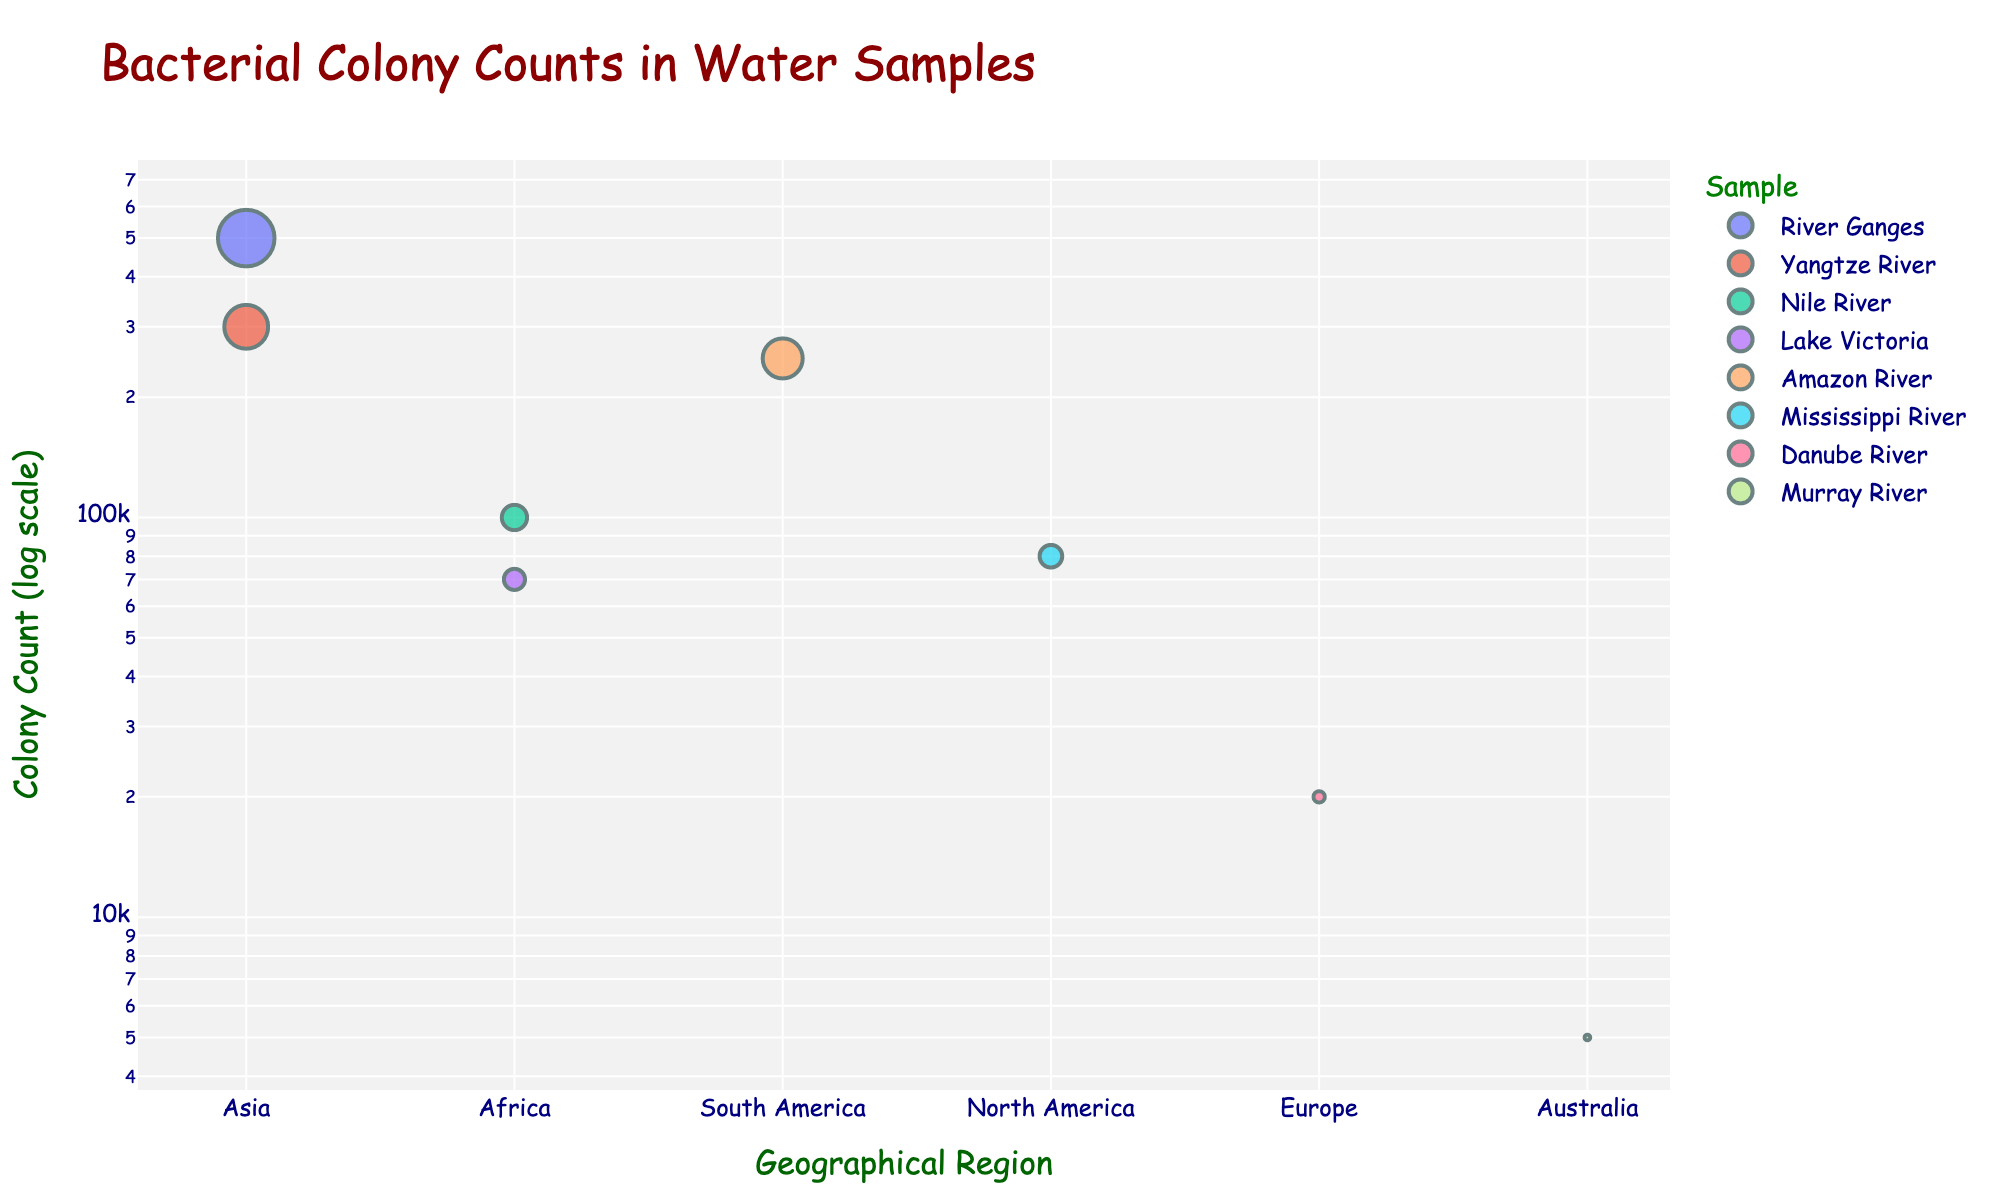What is the title of the figure? The title of the figure is found at the top and indicates the main subject.
Answer: Bacterial Colony Counts in Water Samples In which region was the highest bacterial colony count observed? The highest bacterial colony count has the biggest circle and is at the top on the log scale axis.
Answer: Asia (River Ganges) Which sample in Africa has the higher colony count? By comparing the circle sizes within Africa, the sample with the largest circle has the higher count.
Answer: Nile River What is the difference between the smallest and largest bacterial colony counts in the plot? The smallest count is from Australia (5,000) and the largest is from Asia (500,000). Subtract the smallest from the largest: 500,000 - 5,000.
Answer: 495,000 How many samples are shown from Europe? Count the number of different samples for Europe.
Answer: 1 (Danube River) Which region has more bacterial colony counts, South America or North America? Compare the circle size and position for South America (250,000) and North America (80,000).
Answer: South America What is the median bacterial colony count among all the samples? Organize counts in increasing order: 5,000, 20,000, 70,000, 80,000, 100,000, 250,000, 300,000, 500,000. The median is the average of the 4th and 5th counts: (80,000 + 100,000) / 2.
Answer: 90,000 What is the range of bacterial colony counts in Asia? Subtract the smallest count in Asia (300,000 - Yangtze River) from the largest (500,000 - River Ganges).
Answer: 200,000 Which water sample has the lowest bacterial colony count? The water sample located at the bottom of the log scale axis in the plot has the lowest count.
Answer: Murray River (Australia) Are there any regions with only one sample? If yes, which ones? Regions with only one circle are those with one sample, such as Europe and Australia.
Answer: Europe, Australia 